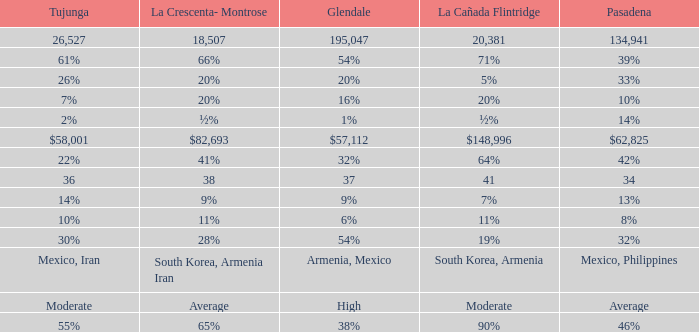What is the figure for La Crescenta-Montrose when Gelndale is $57,112? $82,693. 